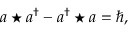Convert formula to latex. <formula><loc_0><loc_0><loc_500><loc_500>a ^ { * } a ^ { \dagger } - a ^ { \dagger } ^ { * } a = \hbar { , }</formula> 